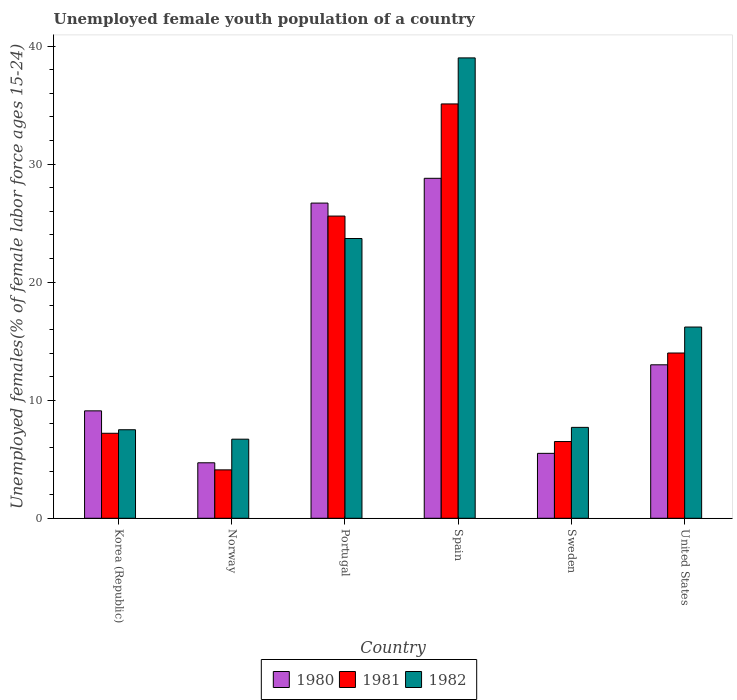How many different coloured bars are there?
Offer a very short reply. 3. Are the number of bars on each tick of the X-axis equal?
Offer a terse response. Yes. How many bars are there on the 2nd tick from the right?
Your answer should be compact. 3. What is the percentage of unemployed female youth population in 1981 in Korea (Republic)?
Offer a terse response. 7.2. Across all countries, what is the maximum percentage of unemployed female youth population in 1982?
Keep it short and to the point. 39. Across all countries, what is the minimum percentage of unemployed female youth population in 1980?
Provide a succinct answer. 4.7. In which country was the percentage of unemployed female youth population in 1982 minimum?
Keep it short and to the point. Norway. What is the total percentage of unemployed female youth population in 1981 in the graph?
Your answer should be very brief. 92.5. What is the difference between the percentage of unemployed female youth population in 1981 in Portugal and that in United States?
Provide a succinct answer. 11.6. What is the difference between the percentage of unemployed female youth population in 1980 in Portugal and the percentage of unemployed female youth population in 1981 in United States?
Your answer should be compact. 12.7. What is the average percentage of unemployed female youth population in 1980 per country?
Offer a very short reply. 14.63. What is the difference between the percentage of unemployed female youth population of/in 1980 and percentage of unemployed female youth population of/in 1982 in Spain?
Offer a terse response. -10.2. In how many countries, is the percentage of unemployed female youth population in 1981 greater than 28 %?
Your answer should be compact. 1. What is the ratio of the percentage of unemployed female youth population in 1982 in Norway to that in Portugal?
Make the answer very short. 0.28. What is the difference between the highest and the second highest percentage of unemployed female youth population in 1981?
Give a very brief answer. -9.5. What is the difference between the highest and the lowest percentage of unemployed female youth population in 1980?
Provide a succinct answer. 24.1. Is the sum of the percentage of unemployed female youth population in 1980 in Sweden and United States greater than the maximum percentage of unemployed female youth population in 1981 across all countries?
Provide a short and direct response. No. What does the 3rd bar from the right in Korea (Republic) represents?
Your answer should be very brief. 1980. Are all the bars in the graph horizontal?
Provide a succinct answer. No. What is the difference between two consecutive major ticks on the Y-axis?
Offer a very short reply. 10. Does the graph contain grids?
Provide a short and direct response. No. How many legend labels are there?
Your answer should be very brief. 3. What is the title of the graph?
Provide a short and direct response. Unemployed female youth population of a country. What is the label or title of the Y-axis?
Your response must be concise. Unemployed females(% of female labor force ages 15-24). What is the Unemployed females(% of female labor force ages 15-24) in 1980 in Korea (Republic)?
Your answer should be compact. 9.1. What is the Unemployed females(% of female labor force ages 15-24) of 1981 in Korea (Republic)?
Keep it short and to the point. 7.2. What is the Unemployed females(% of female labor force ages 15-24) in 1982 in Korea (Republic)?
Provide a succinct answer. 7.5. What is the Unemployed females(% of female labor force ages 15-24) of 1980 in Norway?
Your answer should be compact. 4.7. What is the Unemployed females(% of female labor force ages 15-24) of 1981 in Norway?
Your response must be concise. 4.1. What is the Unemployed females(% of female labor force ages 15-24) of 1982 in Norway?
Your response must be concise. 6.7. What is the Unemployed females(% of female labor force ages 15-24) in 1980 in Portugal?
Offer a terse response. 26.7. What is the Unemployed females(% of female labor force ages 15-24) of 1981 in Portugal?
Your response must be concise. 25.6. What is the Unemployed females(% of female labor force ages 15-24) in 1982 in Portugal?
Make the answer very short. 23.7. What is the Unemployed females(% of female labor force ages 15-24) in 1980 in Spain?
Your answer should be compact. 28.8. What is the Unemployed females(% of female labor force ages 15-24) in 1981 in Spain?
Your response must be concise. 35.1. What is the Unemployed females(% of female labor force ages 15-24) in 1982 in Spain?
Provide a succinct answer. 39. What is the Unemployed females(% of female labor force ages 15-24) in 1981 in Sweden?
Give a very brief answer. 6.5. What is the Unemployed females(% of female labor force ages 15-24) of 1982 in Sweden?
Offer a very short reply. 7.7. What is the Unemployed females(% of female labor force ages 15-24) of 1980 in United States?
Your answer should be very brief. 13. What is the Unemployed females(% of female labor force ages 15-24) of 1982 in United States?
Provide a short and direct response. 16.2. Across all countries, what is the maximum Unemployed females(% of female labor force ages 15-24) in 1980?
Your response must be concise. 28.8. Across all countries, what is the maximum Unemployed females(% of female labor force ages 15-24) in 1981?
Your answer should be very brief. 35.1. Across all countries, what is the maximum Unemployed females(% of female labor force ages 15-24) of 1982?
Make the answer very short. 39. Across all countries, what is the minimum Unemployed females(% of female labor force ages 15-24) of 1980?
Offer a very short reply. 4.7. Across all countries, what is the minimum Unemployed females(% of female labor force ages 15-24) in 1981?
Your response must be concise. 4.1. Across all countries, what is the minimum Unemployed females(% of female labor force ages 15-24) of 1982?
Give a very brief answer. 6.7. What is the total Unemployed females(% of female labor force ages 15-24) of 1980 in the graph?
Offer a terse response. 87.8. What is the total Unemployed females(% of female labor force ages 15-24) in 1981 in the graph?
Make the answer very short. 92.5. What is the total Unemployed females(% of female labor force ages 15-24) of 1982 in the graph?
Offer a very short reply. 100.8. What is the difference between the Unemployed females(% of female labor force ages 15-24) of 1980 in Korea (Republic) and that in Norway?
Keep it short and to the point. 4.4. What is the difference between the Unemployed females(% of female labor force ages 15-24) in 1981 in Korea (Republic) and that in Norway?
Make the answer very short. 3.1. What is the difference between the Unemployed females(% of female labor force ages 15-24) of 1980 in Korea (Republic) and that in Portugal?
Give a very brief answer. -17.6. What is the difference between the Unemployed females(% of female labor force ages 15-24) in 1981 in Korea (Republic) and that in Portugal?
Offer a terse response. -18.4. What is the difference between the Unemployed females(% of female labor force ages 15-24) in 1982 in Korea (Republic) and that in Portugal?
Provide a succinct answer. -16.2. What is the difference between the Unemployed females(% of female labor force ages 15-24) in 1980 in Korea (Republic) and that in Spain?
Your answer should be very brief. -19.7. What is the difference between the Unemployed females(% of female labor force ages 15-24) in 1981 in Korea (Republic) and that in Spain?
Your answer should be very brief. -27.9. What is the difference between the Unemployed females(% of female labor force ages 15-24) in 1982 in Korea (Republic) and that in Spain?
Your answer should be very brief. -31.5. What is the difference between the Unemployed females(% of female labor force ages 15-24) of 1981 in Korea (Republic) and that in Sweden?
Your answer should be compact. 0.7. What is the difference between the Unemployed females(% of female labor force ages 15-24) of 1982 in Korea (Republic) and that in Sweden?
Provide a short and direct response. -0.2. What is the difference between the Unemployed females(% of female labor force ages 15-24) in 1981 in Korea (Republic) and that in United States?
Offer a terse response. -6.8. What is the difference between the Unemployed females(% of female labor force ages 15-24) of 1982 in Korea (Republic) and that in United States?
Provide a succinct answer. -8.7. What is the difference between the Unemployed females(% of female labor force ages 15-24) of 1980 in Norway and that in Portugal?
Your response must be concise. -22. What is the difference between the Unemployed females(% of female labor force ages 15-24) of 1981 in Norway and that in Portugal?
Your answer should be compact. -21.5. What is the difference between the Unemployed females(% of female labor force ages 15-24) in 1980 in Norway and that in Spain?
Your answer should be very brief. -24.1. What is the difference between the Unemployed females(% of female labor force ages 15-24) of 1981 in Norway and that in Spain?
Make the answer very short. -31. What is the difference between the Unemployed females(% of female labor force ages 15-24) of 1982 in Norway and that in Spain?
Provide a succinct answer. -32.3. What is the difference between the Unemployed females(% of female labor force ages 15-24) of 1982 in Norway and that in Sweden?
Ensure brevity in your answer.  -1. What is the difference between the Unemployed females(% of female labor force ages 15-24) in 1980 in Norway and that in United States?
Ensure brevity in your answer.  -8.3. What is the difference between the Unemployed females(% of female labor force ages 15-24) of 1981 in Norway and that in United States?
Ensure brevity in your answer.  -9.9. What is the difference between the Unemployed females(% of female labor force ages 15-24) in 1982 in Norway and that in United States?
Make the answer very short. -9.5. What is the difference between the Unemployed females(% of female labor force ages 15-24) of 1981 in Portugal and that in Spain?
Give a very brief answer. -9.5. What is the difference between the Unemployed females(% of female labor force ages 15-24) of 1982 in Portugal and that in Spain?
Provide a succinct answer. -15.3. What is the difference between the Unemployed females(% of female labor force ages 15-24) of 1980 in Portugal and that in Sweden?
Offer a terse response. 21.2. What is the difference between the Unemployed females(% of female labor force ages 15-24) in 1980 in Portugal and that in United States?
Offer a terse response. 13.7. What is the difference between the Unemployed females(% of female labor force ages 15-24) of 1981 in Portugal and that in United States?
Offer a very short reply. 11.6. What is the difference between the Unemployed females(% of female labor force ages 15-24) in 1982 in Portugal and that in United States?
Provide a succinct answer. 7.5. What is the difference between the Unemployed females(% of female labor force ages 15-24) of 1980 in Spain and that in Sweden?
Your answer should be very brief. 23.3. What is the difference between the Unemployed females(% of female labor force ages 15-24) in 1981 in Spain and that in Sweden?
Keep it short and to the point. 28.6. What is the difference between the Unemployed females(% of female labor force ages 15-24) of 1982 in Spain and that in Sweden?
Your response must be concise. 31.3. What is the difference between the Unemployed females(% of female labor force ages 15-24) in 1981 in Spain and that in United States?
Your response must be concise. 21.1. What is the difference between the Unemployed females(% of female labor force ages 15-24) of 1982 in Spain and that in United States?
Offer a very short reply. 22.8. What is the difference between the Unemployed females(% of female labor force ages 15-24) of 1982 in Sweden and that in United States?
Your answer should be very brief. -8.5. What is the difference between the Unemployed females(% of female labor force ages 15-24) in 1980 in Korea (Republic) and the Unemployed females(% of female labor force ages 15-24) in 1981 in Norway?
Your answer should be very brief. 5. What is the difference between the Unemployed females(% of female labor force ages 15-24) of 1980 in Korea (Republic) and the Unemployed females(% of female labor force ages 15-24) of 1982 in Norway?
Provide a short and direct response. 2.4. What is the difference between the Unemployed females(% of female labor force ages 15-24) in 1980 in Korea (Republic) and the Unemployed females(% of female labor force ages 15-24) in 1981 in Portugal?
Your answer should be very brief. -16.5. What is the difference between the Unemployed females(% of female labor force ages 15-24) in 1980 in Korea (Republic) and the Unemployed females(% of female labor force ages 15-24) in 1982 in Portugal?
Make the answer very short. -14.6. What is the difference between the Unemployed females(% of female labor force ages 15-24) of 1981 in Korea (Republic) and the Unemployed females(% of female labor force ages 15-24) of 1982 in Portugal?
Your answer should be very brief. -16.5. What is the difference between the Unemployed females(% of female labor force ages 15-24) of 1980 in Korea (Republic) and the Unemployed females(% of female labor force ages 15-24) of 1982 in Spain?
Offer a terse response. -29.9. What is the difference between the Unemployed females(% of female labor force ages 15-24) in 1981 in Korea (Republic) and the Unemployed females(% of female labor force ages 15-24) in 1982 in Spain?
Offer a terse response. -31.8. What is the difference between the Unemployed females(% of female labor force ages 15-24) in 1980 in Korea (Republic) and the Unemployed females(% of female labor force ages 15-24) in 1982 in Sweden?
Offer a very short reply. 1.4. What is the difference between the Unemployed females(% of female labor force ages 15-24) in 1980 in Norway and the Unemployed females(% of female labor force ages 15-24) in 1981 in Portugal?
Make the answer very short. -20.9. What is the difference between the Unemployed females(% of female labor force ages 15-24) of 1981 in Norway and the Unemployed females(% of female labor force ages 15-24) of 1982 in Portugal?
Provide a short and direct response. -19.6. What is the difference between the Unemployed females(% of female labor force ages 15-24) in 1980 in Norway and the Unemployed females(% of female labor force ages 15-24) in 1981 in Spain?
Offer a very short reply. -30.4. What is the difference between the Unemployed females(% of female labor force ages 15-24) of 1980 in Norway and the Unemployed females(% of female labor force ages 15-24) of 1982 in Spain?
Provide a succinct answer. -34.3. What is the difference between the Unemployed females(% of female labor force ages 15-24) of 1981 in Norway and the Unemployed females(% of female labor force ages 15-24) of 1982 in Spain?
Make the answer very short. -34.9. What is the difference between the Unemployed females(% of female labor force ages 15-24) in 1980 in Norway and the Unemployed females(% of female labor force ages 15-24) in 1982 in Sweden?
Offer a very short reply. -3. What is the difference between the Unemployed females(% of female labor force ages 15-24) of 1981 in Norway and the Unemployed females(% of female labor force ages 15-24) of 1982 in United States?
Keep it short and to the point. -12.1. What is the difference between the Unemployed females(% of female labor force ages 15-24) of 1980 in Portugal and the Unemployed females(% of female labor force ages 15-24) of 1981 in Spain?
Give a very brief answer. -8.4. What is the difference between the Unemployed females(% of female labor force ages 15-24) in 1980 in Portugal and the Unemployed females(% of female labor force ages 15-24) in 1981 in Sweden?
Offer a terse response. 20.2. What is the difference between the Unemployed females(% of female labor force ages 15-24) of 1980 in Portugal and the Unemployed females(% of female labor force ages 15-24) of 1982 in Sweden?
Make the answer very short. 19. What is the difference between the Unemployed females(% of female labor force ages 15-24) of 1980 in Portugal and the Unemployed females(% of female labor force ages 15-24) of 1981 in United States?
Give a very brief answer. 12.7. What is the difference between the Unemployed females(% of female labor force ages 15-24) in 1981 in Portugal and the Unemployed females(% of female labor force ages 15-24) in 1982 in United States?
Your response must be concise. 9.4. What is the difference between the Unemployed females(% of female labor force ages 15-24) of 1980 in Spain and the Unemployed females(% of female labor force ages 15-24) of 1981 in Sweden?
Provide a succinct answer. 22.3. What is the difference between the Unemployed females(% of female labor force ages 15-24) of 1980 in Spain and the Unemployed females(% of female labor force ages 15-24) of 1982 in Sweden?
Provide a succinct answer. 21.1. What is the difference between the Unemployed females(% of female labor force ages 15-24) of 1981 in Spain and the Unemployed females(% of female labor force ages 15-24) of 1982 in Sweden?
Offer a terse response. 27.4. What is the difference between the Unemployed females(% of female labor force ages 15-24) of 1980 in Spain and the Unemployed females(% of female labor force ages 15-24) of 1981 in United States?
Ensure brevity in your answer.  14.8. What is the difference between the Unemployed females(% of female labor force ages 15-24) of 1980 in Spain and the Unemployed females(% of female labor force ages 15-24) of 1982 in United States?
Make the answer very short. 12.6. What is the difference between the Unemployed females(% of female labor force ages 15-24) in 1981 in Spain and the Unemployed females(% of female labor force ages 15-24) in 1982 in United States?
Provide a succinct answer. 18.9. What is the average Unemployed females(% of female labor force ages 15-24) of 1980 per country?
Your answer should be very brief. 14.63. What is the average Unemployed females(% of female labor force ages 15-24) in 1981 per country?
Give a very brief answer. 15.42. What is the difference between the Unemployed females(% of female labor force ages 15-24) in 1980 and Unemployed females(% of female labor force ages 15-24) in 1981 in Korea (Republic)?
Provide a succinct answer. 1.9. What is the difference between the Unemployed females(% of female labor force ages 15-24) in 1981 and Unemployed females(% of female labor force ages 15-24) in 1982 in Korea (Republic)?
Your answer should be very brief. -0.3. What is the difference between the Unemployed females(% of female labor force ages 15-24) of 1980 and Unemployed females(% of female labor force ages 15-24) of 1981 in Norway?
Your answer should be very brief. 0.6. What is the difference between the Unemployed females(% of female labor force ages 15-24) in 1980 and Unemployed females(% of female labor force ages 15-24) in 1981 in Portugal?
Your answer should be compact. 1.1. What is the difference between the Unemployed females(% of female labor force ages 15-24) of 1981 and Unemployed females(% of female labor force ages 15-24) of 1982 in Portugal?
Make the answer very short. 1.9. What is the difference between the Unemployed females(% of female labor force ages 15-24) in 1980 and Unemployed females(% of female labor force ages 15-24) in 1981 in Spain?
Make the answer very short. -6.3. What is the difference between the Unemployed females(% of female labor force ages 15-24) of 1980 and Unemployed females(% of female labor force ages 15-24) of 1981 in Sweden?
Your response must be concise. -1. What is the difference between the Unemployed females(% of female labor force ages 15-24) in 1980 and Unemployed females(% of female labor force ages 15-24) in 1982 in Sweden?
Your response must be concise. -2.2. What is the difference between the Unemployed females(% of female labor force ages 15-24) in 1981 and Unemployed females(% of female labor force ages 15-24) in 1982 in United States?
Ensure brevity in your answer.  -2.2. What is the ratio of the Unemployed females(% of female labor force ages 15-24) in 1980 in Korea (Republic) to that in Norway?
Make the answer very short. 1.94. What is the ratio of the Unemployed females(% of female labor force ages 15-24) of 1981 in Korea (Republic) to that in Norway?
Make the answer very short. 1.76. What is the ratio of the Unemployed females(% of female labor force ages 15-24) of 1982 in Korea (Republic) to that in Norway?
Offer a terse response. 1.12. What is the ratio of the Unemployed females(% of female labor force ages 15-24) in 1980 in Korea (Republic) to that in Portugal?
Your answer should be very brief. 0.34. What is the ratio of the Unemployed females(% of female labor force ages 15-24) of 1981 in Korea (Republic) to that in Portugal?
Your response must be concise. 0.28. What is the ratio of the Unemployed females(% of female labor force ages 15-24) of 1982 in Korea (Republic) to that in Portugal?
Make the answer very short. 0.32. What is the ratio of the Unemployed females(% of female labor force ages 15-24) in 1980 in Korea (Republic) to that in Spain?
Provide a short and direct response. 0.32. What is the ratio of the Unemployed females(% of female labor force ages 15-24) in 1981 in Korea (Republic) to that in Spain?
Ensure brevity in your answer.  0.21. What is the ratio of the Unemployed females(% of female labor force ages 15-24) in 1982 in Korea (Republic) to that in Spain?
Your response must be concise. 0.19. What is the ratio of the Unemployed females(% of female labor force ages 15-24) of 1980 in Korea (Republic) to that in Sweden?
Provide a short and direct response. 1.65. What is the ratio of the Unemployed females(% of female labor force ages 15-24) in 1981 in Korea (Republic) to that in Sweden?
Your response must be concise. 1.11. What is the ratio of the Unemployed females(% of female labor force ages 15-24) of 1980 in Korea (Republic) to that in United States?
Give a very brief answer. 0.7. What is the ratio of the Unemployed females(% of female labor force ages 15-24) of 1981 in Korea (Republic) to that in United States?
Ensure brevity in your answer.  0.51. What is the ratio of the Unemployed females(% of female labor force ages 15-24) in 1982 in Korea (Republic) to that in United States?
Provide a short and direct response. 0.46. What is the ratio of the Unemployed females(% of female labor force ages 15-24) in 1980 in Norway to that in Portugal?
Your response must be concise. 0.18. What is the ratio of the Unemployed females(% of female labor force ages 15-24) of 1981 in Norway to that in Portugal?
Make the answer very short. 0.16. What is the ratio of the Unemployed females(% of female labor force ages 15-24) of 1982 in Norway to that in Portugal?
Your answer should be very brief. 0.28. What is the ratio of the Unemployed females(% of female labor force ages 15-24) of 1980 in Norway to that in Spain?
Keep it short and to the point. 0.16. What is the ratio of the Unemployed females(% of female labor force ages 15-24) in 1981 in Norway to that in Spain?
Offer a very short reply. 0.12. What is the ratio of the Unemployed females(% of female labor force ages 15-24) in 1982 in Norway to that in Spain?
Make the answer very short. 0.17. What is the ratio of the Unemployed females(% of female labor force ages 15-24) in 1980 in Norway to that in Sweden?
Offer a very short reply. 0.85. What is the ratio of the Unemployed females(% of female labor force ages 15-24) of 1981 in Norway to that in Sweden?
Give a very brief answer. 0.63. What is the ratio of the Unemployed females(% of female labor force ages 15-24) in 1982 in Norway to that in Sweden?
Make the answer very short. 0.87. What is the ratio of the Unemployed females(% of female labor force ages 15-24) in 1980 in Norway to that in United States?
Your answer should be very brief. 0.36. What is the ratio of the Unemployed females(% of female labor force ages 15-24) of 1981 in Norway to that in United States?
Provide a succinct answer. 0.29. What is the ratio of the Unemployed females(% of female labor force ages 15-24) of 1982 in Norway to that in United States?
Your answer should be very brief. 0.41. What is the ratio of the Unemployed females(% of female labor force ages 15-24) of 1980 in Portugal to that in Spain?
Ensure brevity in your answer.  0.93. What is the ratio of the Unemployed females(% of female labor force ages 15-24) in 1981 in Portugal to that in Spain?
Your answer should be very brief. 0.73. What is the ratio of the Unemployed females(% of female labor force ages 15-24) in 1982 in Portugal to that in Spain?
Offer a very short reply. 0.61. What is the ratio of the Unemployed females(% of female labor force ages 15-24) in 1980 in Portugal to that in Sweden?
Provide a short and direct response. 4.85. What is the ratio of the Unemployed females(% of female labor force ages 15-24) in 1981 in Portugal to that in Sweden?
Offer a terse response. 3.94. What is the ratio of the Unemployed females(% of female labor force ages 15-24) of 1982 in Portugal to that in Sweden?
Your answer should be very brief. 3.08. What is the ratio of the Unemployed females(% of female labor force ages 15-24) in 1980 in Portugal to that in United States?
Make the answer very short. 2.05. What is the ratio of the Unemployed females(% of female labor force ages 15-24) in 1981 in Portugal to that in United States?
Make the answer very short. 1.83. What is the ratio of the Unemployed females(% of female labor force ages 15-24) of 1982 in Portugal to that in United States?
Ensure brevity in your answer.  1.46. What is the ratio of the Unemployed females(% of female labor force ages 15-24) in 1980 in Spain to that in Sweden?
Your response must be concise. 5.24. What is the ratio of the Unemployed females(% of female labor force ages 15-24) in 1981 in Spain to that in Sweden?
Provide a succinct answer. 5.4. What is the ratio of the Unemployed females(% of female labor force ages 15-24) in 1982 in Spain to that in Sweden?
Make the answer very short. 5.06. What is the ratio of the Unemployed females(% of female labor force ages 15-24) of 1980 in Spain to that in United States?
Offer a terse response. 2.22. What is the ratio of the Unemployed females(% of female labor force ages 15-24) in 1981 in Spain to that in United States?
Your answer should be compact. 2.51. What is the ratio of the Unemployed females(% of female labor force ages 15-24) in 1982 in Spain to that in United States?
Your answer should be very brief. 2.41. What is the ratio of the Unemployed females(% of female labor force ages 15-24) of 1980 in Sweden to that in United States?
Ensure brevity in your answer.  0.42. What is the ratio of the Unemployed females(% of female labor force ages 15-24) in 1981 in Sweden to that in United States?
Your response must be concise. 0.46. What is the ratio of the Unemployed females(% of female labor force ages 15-24) in 1982 in Sweden to that in United States?
Your answer should be very brief. 0.48. What is the difference between the highest and the second highest Unemployed females(% of female labor force ages 15-24) of 1980?
Provide a succinct answer. 2.1. What is the difference between the highest and the second highest Unemployed females(% of female labor force ages 15-24) of 1981?
Give a very brief answer. 9.5. What is the difference between the highest and the lowest Unemployed females(% of female labor force ages 15-24) in 1980?
Keep it short and to the point. 24.1. What is the difference between the highest and the lowest Unemployed females(% of female labor force ages 15-24) in 1981?
Give a very brief answer. 31. What is the difference between the highest and the lowest Unemployed females(% of female labor force ages 15-24) in 1982?
Offer a very short reply. 32.3. 